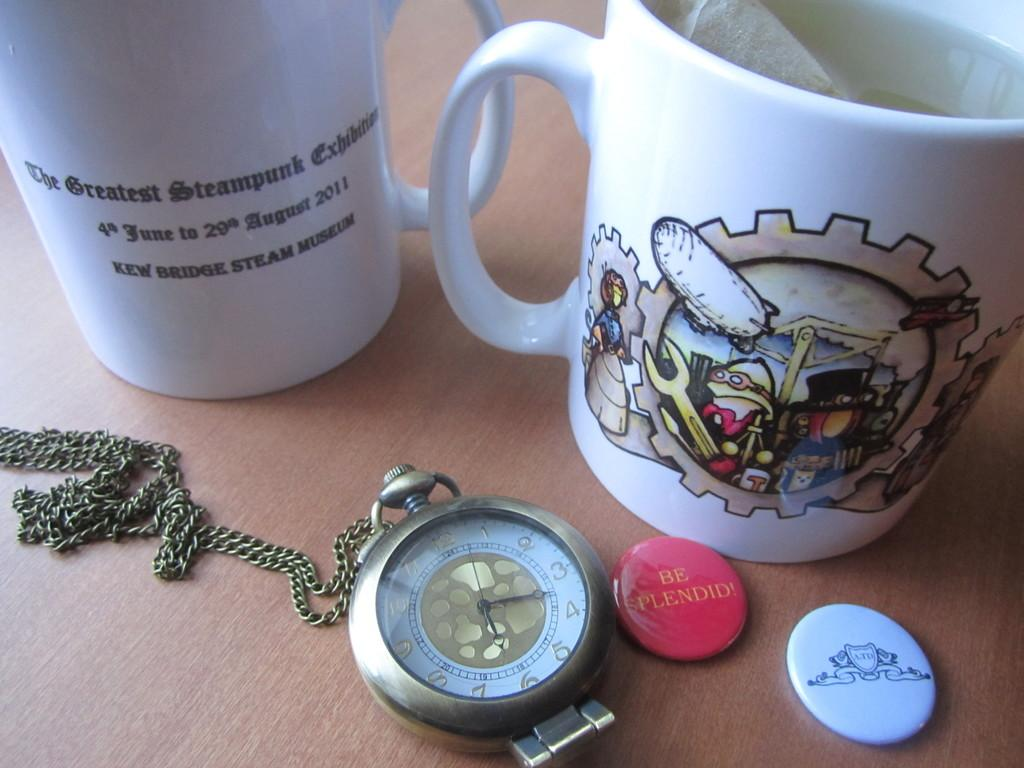<image>
Present a compact description of the photo's key features. A white mug near other items advertises "The Greatest Steampunk Exhibit". 